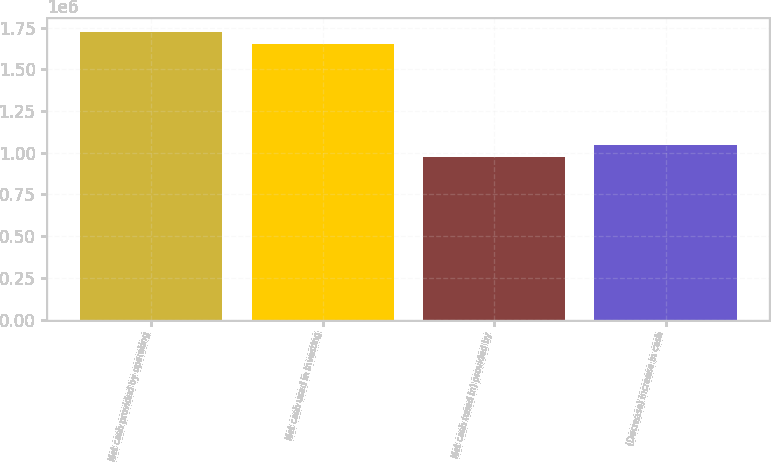Convert chart to OTSL. <chart><loc_0><loc_0><loc_500><loc_500><bar_chart><fcel>Net cash provided by operating<fcel>Net cash used in investing<fcel>Net cash (used in) provided by<fcel>(Decrease) increase in cash<nl><fcel>1.72517e+06<fcel>1.65407e+06<fcel>975642<fcel>1.04675e+06<nl></chart> 